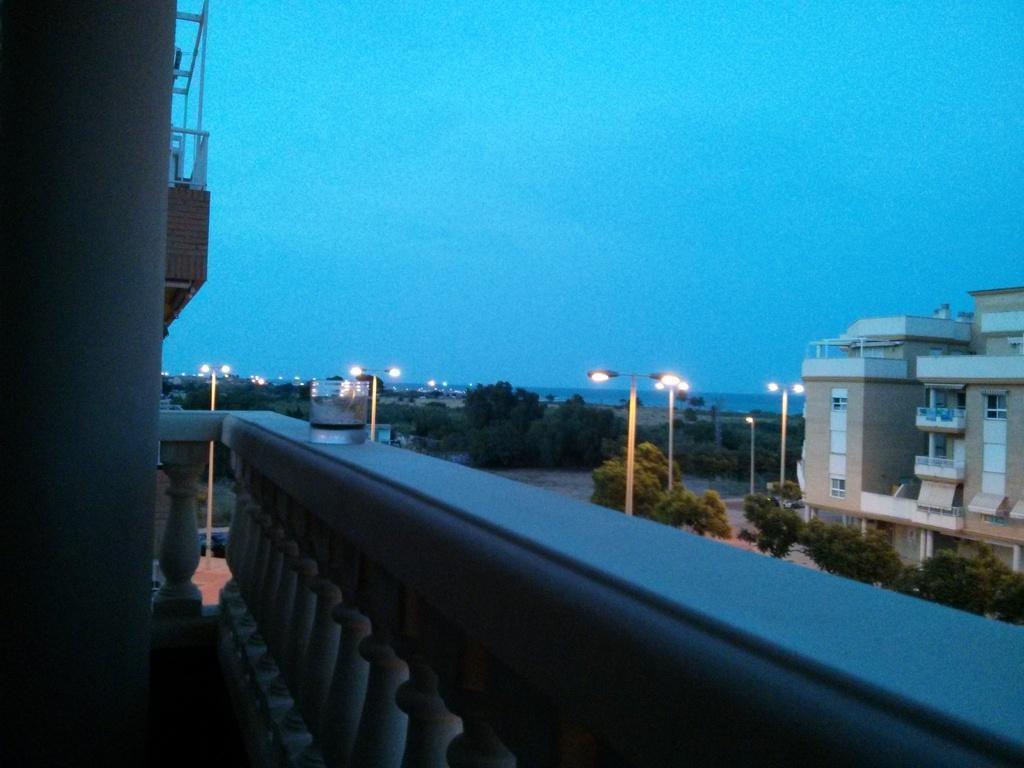Can you describe this image briefly? In this image we can see a glass which is placed on a fence. On the backside we can see some trees, street lights, a building with windows and the sky which looks cloudy. 